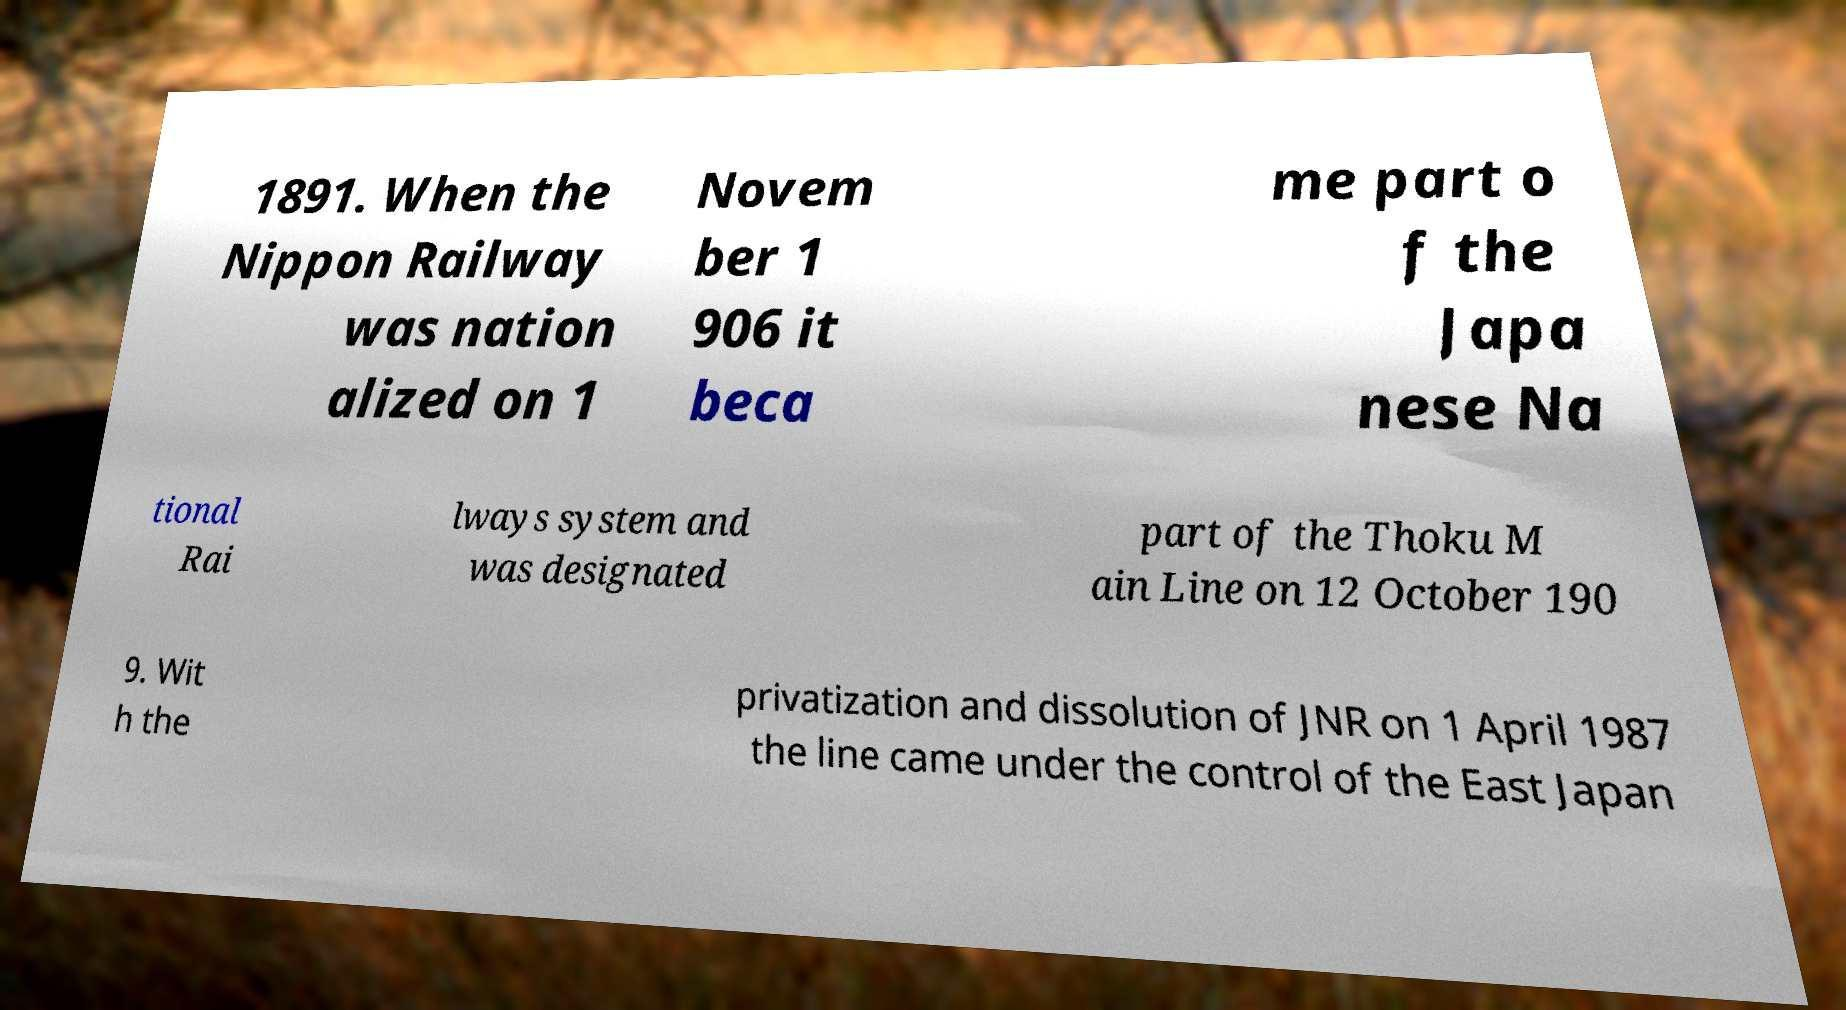Could you assist in decoding the text presented in this image and type it out clearly? 1891. When the Nippon Railway was nation alized on 1 Novem ber 1 906 it beca me part o f the Japa nese Na tional Rai lways system and was designated part of the Thoku M ain Line on 12 October 190 9. Wit h the privatization and dissolution of JNR on 1 April 1987 the line came under the control of the East Japan 